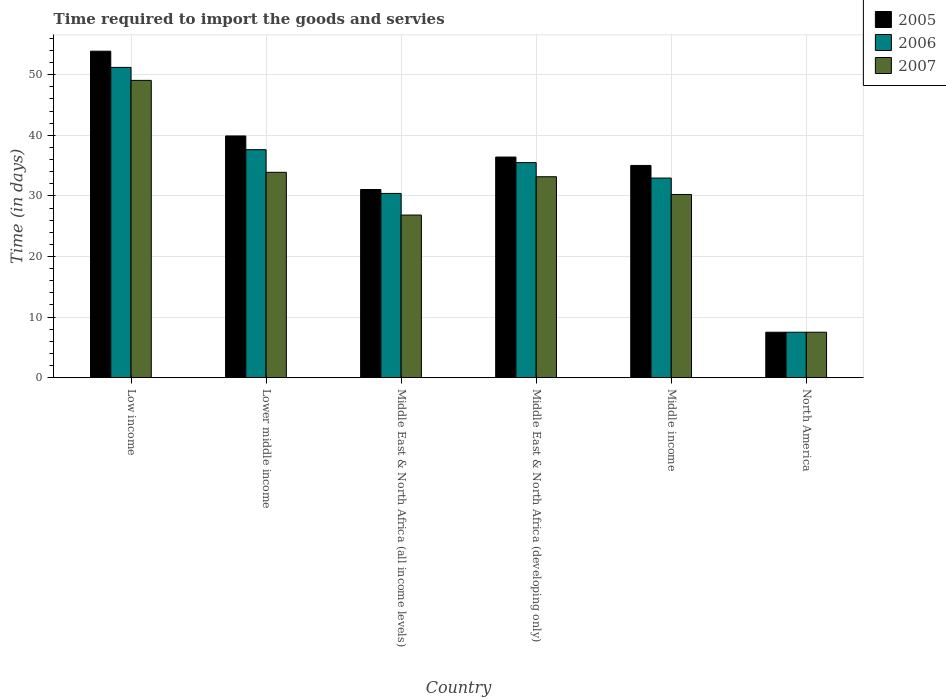How many different coloured bars are there?
Your response must be concise. 3. How many bars are there on the 2nd tick from the right?
Your answer should be very brief. 3. What is the label of the 1st group of bars from the left?
Your answer should be very brief. Low income. What is the number of days required to import the goods and services in 2005 in Middle income?
Give a very brief answer. 35.03. Across all countries, what is the maximum number of days required to import the goods and services in 2006?
Give a very brief answer. 51.21. Across all countries, what is the minimum number of days required to import the goods and services in 2005?
Ensure brevity in your answer.  7.5. In which country was the number of days required to import the goods and services in 2007 maximum?
Provide a short and direct response. Low income. In which country was the number of days required to import the goods and services in 2005 minimum?
Your answer should be very brief. North America. What is the total number of days required to import the goods and services in 2007 in the graph?
Make the answer very short. 180.72. What is the difference between the number of days required to import the goods and services in 2007 in Low income and that in Middle East & North Africa (all income levels)?
Your answer should be very brief. 22.23. What is the difference between the number of days required to import the goods and services in 2007 in Lower middle income and the number of days required to import the goods and services in 2005 in Low income?
Offer a terse response. -19.99. What is the average number of days required to import the goods and services in 2007 per country?
Make the answer very short. 30.12. What is the difference between the number of days required to import the goods and services of/in 2005 and number of days required to import the goods and services of/in 2006 in Low income?
Your response must be concise. 2.67. What is the ratio of the number of days required to import the goods and services in 2005 in Low income to that in North America?
Give a very brief answer. 7.19. Is the number of days required to import the goods and services in 2005 in Lower middle income less than that in Middle East & North Africa (all income levels)?
Provide a short and direct response. No. Is the difference between the number of days required to import the goods and services in 2005 in Low income and Lower middle income greater than the difference between the number of days required to import the goods and services in 2006 in Low income and Lower middle income?
Your answer should be very brief. Yes. What is the difference between the highest and the second highest number of days required to import the goods and services in 2005?
Your answer should be very brief. -17.47. What is the difference between the highest and the lowest number of days required to import the goods and services in 2006?
Offer a very short reply. 43.71. In how many countries, is the number of days required to import the goods and services in 2007 greater than the average number of days required to import the goods and services in 2007 taken over all countries?
Ensure brevity in your answer.  4. Is the sum of the number of days required to import the goods and services in 2005 in Lower middle income and Middle East & North Africa (all income levels) greater than the maximum number of days required to import the goods and services in 2007 across all countries?
Offer a terse response. Yes. How many bars are there?
Your answer should be compact. 18. What is the difference between two consecutive major ticks on the Y-axis?
Your response must be concise. 10. Are the values on the major ticks of Y-axis written in scientific E-notation?
Ensure brevity in your answer.  No. Does the graph contain any zero values?
Your response must be concise. No. Does the graph contain grids?
Give a very brief answer. Yes. Where does the legend appear in the graph?
Offer a very short reply. Top right. How many legend labels are there?
Keep it short and to the point. 3. What is the title of the graph?
Provide a succinct answer. Time required to import the goods and servies. Does "2001" appear as one of the legend labels in the graph?
Give a very brief answer. No. What is the label or title of the Y-axis?
Provide a short and direct response. Time (in days). What is the Time (in days) in 2005 in Low income?
Your answer should be compact. 53.89. What is the Time (in days) in 2006 in Low income?
Your response must be concise. 51.21. What is the Time (in days) of 2007 in Low income?
Provide a succinct answer. 49.07. What is the Time (in days) of 2005 in Lower middle income?
Offer a terse response. 39.9. What is the Time (in days) in 2006 in Lower middle income?
Your response must be concise. 37.63. What is the Time (in days) of 2007 in Lower middle income?
Offer a very short reply. 33.9. What is the Time (in days) of 2005 in Middle East & North Africa (all income levels)?
Offer a terse response. 31.06. What is the Time (in days) in 2006 in Middle East & North Africa (all income levels)?
Offer a very short reply. 30.41. What is the Time (in days) in 2007 in Middle East & North Africa (all income levels)?
Ensure brevity in your answer.  26.84. What is the Time (in days) in 2005 in Middle East & North Africa (developing only)?
Offer a very short reply. 36.42. What is the Time (in days) in 2006 in Middle East & North Africa (developing only)?
Ensure brevity in your answer.  35.5. What is the Time (in days) of 2007 in Middle East & North Africa (developing only)?
Give a very brief answer. 33.17. What is the Time (in days) in 2005 in Middle income?
Your response must be concise. 35.03. What is the Time (in days) in 2006 in Middle income?
Offer a very short reply. 32.95. What is the Time (in days) of 2007 in Middle income?
Your answer should be very brief. 30.24. What is the Time (in days) of 2005 in North America?
Provide a succinct answer. 7.5. What is the Time (in days) in 2006 in North America?
Give a very brief answer. 7.5. Across all countries, what is the maximum Time (in days) of 2005?
Offer a very short reply. 53.89. Across all countries, what is the maximum Time (in days) of 2006?
Your response must be concise. 51.21. Across all countries, what is the maximum Time (in days) of 2007?
Your answer should be compact. 49.07. Across all countries, what is the minimum Time (in days) of 2007?
Your response must be concise. 7.5. What is the total Time (in days) of 2005 in the graph?
Offer a very short reply. 203.79. What is the total Time (in days) in 2006 in the graph?
Your response must be concise. 195.21. What is the total Time (in days) of 2007 in the graph?
Provide a short and direct response. 180.72. What is the difference between the Time (in days) of 2005 in Low income and that in Lower middle income?
Provide a short and direct response. 13.99. What is the difference between the Time (in days) in 2006 in Low income and that in Lower middle income?
Provide a short and direct response. 13.58. What is the difference between the Time (in days) in 2007 in Low income and that in Lower middle income?
Give a very brief answer. 15.17. What is the difference between the Time (in days) in 2005 in Low income and that in Middle East & North Africa (all income levels)?
Make the answer very short. 22.83. What is the difference between the Time (in days) in 2006 in Low income and that in Middle East & North Africa (all income levels)?
Ensure brevity in your answer.  20.8. What is the difference between the Time (in days) in 2007 in Low income and that in Middle East & North Africa (all income levels)?
Provide a short and direct response. 22.23. What is the difference between the Time (in days) in 2005 in Low income and that in Middle East & North Africa (developing only)?
Your response must be concise. 17.47. What is the difference between the Time (in days) in 2006 in Low income and that in Middle East & North Africa (developing only)?
Keep it short and to the point. 15.71. What is the difference between the Time (in days) of 2007 in Low income and that in Middle East & North Africa (developing only)?
Your response must be concise. 15.9. What is the difference between the Time (in days) in 2005 in Low income and that in Middle income?
Keep it short and to the point. 18.86. What is the difference between the Time (in days) in 2006 in Low income and that in Middle income?
Ensure brevity in your answer.  18.27. What is the difference between the Time (in days) in 2007 in Low income and that in Middle income?
Your response must be concise. 18.83. What is the difference between the Time (in days) in 2005 in Low income and that in North America?
Give a very brief answer. 46.39. What is the difference between the Time (in days) in 2006 in Low income and that in North America?
Your response must be concise. 43.71. What is the difference between the Time (in days) of 2007 in Low income and that in North America?
Offer a very short reply. 41.57. What is the difference between the Time (in days) in 2005 in Lower middle income and that in Middle East & North Africa (all income levels)?
Provide a succinct answer. 8.84. What is the difference between the Time (in days) of 2006 in Lower middle income and that in Middle East & North Africa (all income levels)?
Your answer should be very brief. 7.22. What is the difference between the Time (in days) of 2007 in Lower middle income and that in Middle East & North Africa (all income levels)?
Your answer should be very brief. 7.06. What is the difference between the Time (in days) of 2005 in Lower middle income and that in Middle East & North Africa (developing only)?
Give a very brief answer. 3.48. What is the difference between the Time (in days) in 2006 in Lower middle income and that in Middle East & North Africa (developing only)?
Your response must be concise. 2.13. What is the difference between the Time (in days) in 2007 in Lower middle income and that in Middle East & North Africa (developing only)?
Give a very brief answer. 0.73. What is the difference between the Time (in days) in 2005 in Lower middle income and that in Middle income?
Your answer should be compact. 4.87. What is the difference between the Time (in days) in 2006 in Lower middle income and that in Middle income?
Ensure brevity in your answer.  4.68. What is the difference between the Time (in days) of 2007 in Lower middle income and that in Middle income?
Your answer should be very brief. 3.66. What is the difference between the Time (in days) of 2005 in Lower middle income and that in North America?
Make the answer very short. 32.4. What is the difference between the Time (in days) in 2006 in Lower middle income and that in North America?
Keep it short and to the point. 30.13. What is the difference between the Time (in days) in 2007 in Lower middle income and that in North America?
Give a very brief answer. 26.4. What is the difference between the Time (in days) of 2005 in Middle East & North Africa (all income levels) and that in Middle East & North Africa (developing only)?
Your response must be concise. -5.36. What is the difference between the Time (in days) of 2006 in Middle East & North Africa (all income levels) and that in Middle East & North Africa (developing only)?
Offer a very short reply. -5.09. What is the difference between the Time (in days) of 2007 in Middle East & North Africa (all income levels) and that in Middle East & North Africa (developing only)?
Keep it short and to the point. -6.32. What is the difference between the Time (in days) of 2005 in Middle East & North Africa (all income levels) and that in Middle income?
Offer a very short reply. -3.97. What is the difference between the Time (in days) of 2006 in Middle East & North Africa (all income levels) and that in Middle income?
Offer a very short reply. -2.54. What is the difference between the Time (in days) of 2007 in Middle East & North Africa (all income levels) and that in Middle income?
Make the answer very short. -3.4. What is the difference between the Time (in days) of 2005 in Middle East & North Africa (all income levels) and that in North America?
Your answer should be very brief. 23.56. What is the difference between the Time (in days) of 2006 in Middle East & North Africa (all income levels) and that in North America?
Ensure brevity in your answer.  22.91. What is the difference between the Time (in days) of 2007 in Middle East & North Africa (all income levels) and that in North America?
Give a very brief answer. 19.34. What is the difference between the Time (in days) of 2005 in Middle East & North Africa (developing only) and that in Middle income?
Keep it short and to the point. 1.39. What is the difference between the Time (in days) in 2006 in Middle East & North Africa (developing only) and that in Middle income?
Provide a short and direct response. 2.55. What is the difference between the Time (in days) of 2007 in Middle East & North Africa (developing only) and that in Middle income?
Offer a very short reply. 2.93. What is the difference between the Time (in days) in 2005 in Middle East & North Africa (developing only) and that in North America?
Offer a very short reply. 28.92. What is the difference between the Time (in days) in 2007 in Middle East & North Africa (developing only) and that in North America?
Offer a very short reply. 25.67. What is the difference between the Time (in days) of 2005 in Middle income and that in North America?
Provide a short and direct response. 27.53. What is the difference between the Time (in days) in 2006 in Middle income and that in North America?
Your response must be concise. 25.45. What is the difference between the Time (in days) of 2007 in Middle income and that in North America?
Offer a very short reply. 22.74. What is the difference between the Time (in days) in 2005 in Low income and the Time (in days) in 2006 in Lower middle income?
Provide a short and direct response. 16.26. What is the difference between the Time (in days) of 2005 in Low income and the Time (in days) of 2007 in Lower middle income?
Your answer should be compact. 19.99. What is the difference between the Time (in days) of 2006 in Low income and the Time (in days) of 2007 in Lower middle income?
Ensure brevity in your answer.  17.32. What is the difference between the Time (in days) in 2005 in Low income and the Time (in days) in 2006 in Middle East & North Africa (all income levels)?
Your answer should be very brief. 23.48. What is the difference between the Time (in days) in 2005 in Low income and the Time (in days) in 2007 in Middle East & North Africa (all income levels)?
Ensure brevity in your answer.  27.05. What is the difference between the Time (in days) in 2006 in Low income and the Time (in days) in 2007 in Middle East & North Africa (all income levels)?
Your answer should be very brief. 24.37. What is the difference between the Time (in days) of 2005 in Low income and the Time (in days) of 2006 in Middle East & North Africa (developing only)?
Give a very brief answer. 18.39. What is the difference between the Time (in days) of 2005 in Low income and the Time (in days) of 2007 in Middle East & North Africa (developing only)?
Provide a short and direct response. 20.72. What is the difference between the Time (in days) of 2006 in Low income and the Time (in days) of 2007 in Middle East & North Africa (developing only)?
Your answer should be very brief. 18.05. What is the difference between the Time (in days) of 2005 in Low income and the Time (in days) of 2006 in Middle income?
Keep it short and to the point. 20.94. What is the difference between the Time (in days) in 2005 in Low income and the Time (in days) in 2007 in Middle income?
Provide a short and direct response. 23.65. What is the difference between the Time (in days) in 2006 in Low income and the Time (in days) in 2007 in Middle income?
Provide a short and direct response. 20.98. What is the difference between the Time (in days) of 2005 in Low income and the Time (in days) of 2006 in North America?
Your answer should be compact. 46.39. What is the difference between the Time (in days) of 2005 in Low income and the Time (in days) of 2007 in North America?
Your answer should be very brief. 46.39. What is the difference between the Time (in days) of 2006 in Low income and the Time (in days) of 2007 in North America?
Your answer should be very brief. 43.71. What is the difference between the Time (in days) in 2005 in Lower middle income and the Time (in days) in 2006 in Middle East & North Africa (all income levels)?
Ensure brevity in your answer.  9.49. What is the difference between the Time (in days) of 2005 in Lower middle income and the Time (in days) of 2007 in Middle East & North Africa (all income levels)?
Your response must be concise. 13.06. What is the difference between the Time (in days) in 2006 in Lower middle income and the Time (in days) in 2007 in Middle East & North Africa (all income levels)?
Make the answer very short. 10.79. What is the difference between the Time (in days) of 2005 in Lower middle income and the Time (in days) of 2006 in Middle East & North Africa (developing only)?
Offer a terse response. 4.4. What is the difference between the Time (in days) in 2005 in Lower middle income and the Time (in days) in 2007 in Middle East & North Africa (developing only)?
Give a very brief answer. 6.73. What is the difference between the Time (in days) in 2006 in Lower middle income and the Time (in days) in 2007 in Middle East & North Africa (developing only)?
Offer a very short reply. 4.47. What is the difference between the Time (in days) of 2005 in Lower middle income and the Time (in days) of 2006 in Middle income?
Offer a terse response. 6.95. What is the difference between the Time (in days) in 2005 in Lower middle income and the Time (in days) in 2007 in Middle income?
Make the answer very short. 9.66. What is the difference between the Time (in days) in 2006 in Lower middle income and the Time (in days) in 2007 in Middle income?
Keep it short and to the point. 7.4. What is the difference between the Time (in days) of 2005 in Lower middle income and the Time (in days) of 2006 in North America?
Give a very brief answer. 32.4. What is the difference between the Time (in days) in 2005 in Lower middle income and the Time (in days) in 2007 in North America?
Offer a terse response. 32.4. What is the difference between the Time (in days) in 2006 in Lower middle income and the Time (in days) in 2007 in North America?
Offer a very short reply. 30.13. What is the difference between the Time (in days) of 2005 in Middle East & North Africa (all income levels) and the Time (in days) of 2006 in Middle East & North Africa (developing only)?
Ensure brevity in your answer.  -4.44. What is the difference between the Time (in days) of 2005 in Middle East & North Africa (all income levels) and the Time (in days) of 2007 in Middle East & North Africa (developing only)?
Your response must be concise. -2.11. What is the difference between the Time (in days) of 2006 in Middle East & North Africa (all income levels) and the Time (in days) of 2007 in Middle East & North Africa (developing only)?
Give a very brief answer. -2.75. What is the difference between the Time (in days) in 2005 in Middle East & North Africa (all income levels) and the Time (in days) in 2006 in Middle income?
Your response must be concise. -1.89. What is the difference between the Time (in days) in 2005 in Middle East & North Africa (all income levels) and the Time (in days) in 2007 in Middle income?
Offer a very short reply. 0.82. What is the difference between the Time (in days) in 2006 in Middle East & North Africa (all income levels) and the Time (in days) in 2007 in Middle income?
Offer a very short reply. 0.17. What is the difference between the Time (in days) in 2005 in Middle East & North Africa (all income levels) and the Time (in days) in 2006 in North America?
Your response must be concise. 23.56. What is the difference between the Time (in days) in 2005 in Middle East & North Africa (all income levels) and the Time (in days) in 2007 in North America?
Provide a short and direct response. 23.56. What is the difference between the Time (in days) of 2006 in Middle East & North Africa (all income levels) and the Time (in days) of 2007 in North America?
Offer a very short reply. 22.91. What is the difference between the Time (in days) in 2005 in Middle East & North Africa (developing only) and the Time (in days) in 2006 in Middle income?
Make the answer very short. 3.47. What is the difference between the Time (in days) in 2005 in Middle East & North Africa (developing only) and the Time (in days) in 2007 in Middle income?
Your response must be concise. 6.18. What is the difference between the Time (in days) in 2006 in Middle East & North Africa (developing only) and the Time (in days) in 2007 in Middle income?
Offer a terse response. 5.26. What is the difference between the Time (in days) in 2005 in Middle East & North Africa (developing only) and the Time (in days) in 2006 in North America?
Provide a succinct answer. 28.92. What is the difference between the Time (in days) in 2005 in Middle East & North Africa (developing only) and the Time (in days) in 2007 in North America?
Make the answer very short. 28.92. What is the difference between the Time (in days) in 2006 in Middle East & North Africa (developing only) and the Time (in days) in 2007 in North America?
Your answer should be very brief. 28. What is the difference between the Time (in days) in 2005 in Middle income and the Time (in days) in 2006 in North America?
Offer a very short reply. 27.53. What is the difference between the Time (in days) of 2005 in Middle income and the Time (in days) of 2007 in North America?
Keep it short and to the point. 27.53. What is the difference between the Time (in days) in 2006 in Middle income and the Time (in days) in 2007 in North America?
Keep it short and to the point. 25.45. What is the average Time (in days) in 2005 per country?
Your response must be concise. 33.97. What is the average Time (in days) of 2006 per country?
Provide a short and direct response. 32.53. What is the average Time (in days) of 2007 per country?
Give a very brief answer. 30.12. What is the difference between the Time (in days) of 2005 and Time (in days) of 2006 in Low income?
Ensure brevity in your answer.  2.67. What is the difference between the Time (in days) in 2005 and Time (in days) in 2007 in Low income?
Your answer should be compact. 4.82. What is the difference between the Time (in days) of 2006 and Time (in days) of 2007 in Low income?
Your answer should be compact. 2.14. What is the difference between the Time (in days) of 2005 and Time (in days) of 2006 in Lower middle income?
Provide a short and direct response. 2.27. What is the difference between the Time (in days) of 2006 and Time (in days) of 2007 in Lower middle income?
Keep it short and to the point. 3.73. What is the difference between the Time (in days) in 2005 and Time (in days) in 2006 in Middle East & North Africa (all income levels)?
Offer a terse response. 0.65. What is the difference between the Time (in days) in 2005 and Time (in days) in 2007 in Middle East & North Africa (all income levels)?
Keep it short and to the point. 4.22. What is the difference between the Time (in days) in 2006 and Time (in days) in 2007 in Middle East & North Africa (all income levels)?
Keep it short and to the point. 3.57. What is the difference between the Time (in days) of 2005 and Time (in days) of 2006 in Middle East & North Africa (developing only)?
Ensure brevity in your answer.  0.92. What is the difference between the Time (in days) of 2005 and Time (in days) of 2007 in Middle East & North Africa (developing only)?
Offer a terse response. 3.25. What is the difference between the Time (in days) of 2006 and Time (in days) of 2007 in Middle East & North Africa (developing only)?
Make the answer very short. 2.33. What is the difference between the Time (in days) of 2005 and Time (in days) of 2006 in Middle income?
Keep it short and to the point. 2.08. What is the difference between the Time (in days) of 2005 and Time (in days) of 2007 in Middle income?
Your response must be concise. 4.79. What is the difference between the Time (in days) in 2006 and Time (in days) in 2007 in Middle income?
Make the answer very short. 2.71. What is the difference between the Time (in days) of 2005 and Time (in days) of 2006 in North America?
Keep it short and to the point. 0. What is the difference between the Time (in days) of 2006 and Time (in days) of 2007 in North America?
Offer a terse response. 0. What is the ratio of the Time (in days) of 2005 in Low income to that in Lower middle income?
Provide a succinct answer. 1.35. What is the ratio of the Time (in days) of 2006 in Low income to that in Lower middle income?
Your answer should be very brief. 1.36. What is the ratio of the Time (in days) in 2007 in Low income to that in Lower middle income?
Your answer should be very brief. 1.45. What is the ratio of the Time (in days) in 2005 in Low income to that in Middle East & North Africa (all income levels)?
Offer a terse response. 1.74. What is the ratio of the Time (in days) of 2006 in Low income to that in Middle East & North Africa (all income levels)?
Keep it short and to the point. 1.68. What is the ratio of the Time (in days) of 2007 in Low income to that in Middle East & North Africa (all income levels)?
Offer a very short reply. 1.83. What is the ratio of the Time (in days) of 2005 in Low income to that in Middle East & North Africa (developing only)?
Give a very brief answer. 1.48. What is the ratio of the Time (in days) of 2006 in Low income to that in Middle East & North Africa (developing only)?
Provide a short and direct response. 1.44. What is the ratio of the Time (in days) of 2007 in Low income to that in Middle East & North Africa (developing only)?
Keep it short and to the point. 1.48. What is the ratio of the Time (in days) in 2005 in Low income to that in Middle income?
Keep it short and to the point. 1.54. What is the ratio of the Time (in days) of 2006 in Low income to that in Middle income?
Ensure brevity in your answer.  1.55. What is the ratio of the Time (in days) of 2007 in Low income to that in Middle income?
Ensure brevity in your answer.  1.62. What is the ratio of the Time (in days) of 2005 in Low income to that in North America?
Provide a short and direct response. 7.19. What is the ratio of the Time (in days) of 2006 in Low income to that in North America?
Ensure brevity in your answer.  6.83. What is the ratio of the Time (in days) in 2007 in Low income to that in North America?
Offer a very short reply. 6.54. What is the ratio of the Time (in days) of 2005 in Lower middle income to that in Middle East & North Africa (all income levels)?
Make the answer very short. 1.28. What is the ratio of the Time (in days) in 2006 in Lower middle income to that in Middle East & North Africa (all income levels)?
Keep it short and to the point. 1.24. What is the ratio of the Time (in days) of 2007 in Lower middle income to that in Middle East & North Africa (all income levels)?
Give a very brief answer. 1.26. What is the ratio of the Time (in days) of 2005 in Lower middle income to that in Middle East & North Africa (developing only)?
Ensure brevity in your answer.  1.1. What is the ratio of the Time (in days) of 2006 in Lower middle income to that in Middle East & North Africa (developing only)?
Offer a terse response. 1.06. What is the ratio of the Time (in days) of 2007 in Lower middle income to that in Middle East & North Africa (developing only)?
Provide a succinct answer. 1.02. What is the ratio of the Time (in days) of 2005 in Lower middle income to that in Middle income?
Keep it short and to the point. 1.14. What is the ratio of the Time (in days) of 2006 in Lower middle income to that in Middle income?
Keep it short and to the point. 1.14. What is the ratio of the Time (in days) of 2007 in Lower middle income to that in Middle income?
Give a very brief answer. 1.12. What is the ratio of the Time (in days) in 2005 in Lower middle income to that in North America?
Give a very brief answer. 5.32. What is the ratio of the Time (in days) in 2006 in Lower middle income to that in North America?
Your answer should be very brief. 5.02. What is the ratio of the Time (in days) in 2007 in Lower middle income to that in North America?
Your answer should be very brief. 4.52. What is the ratio of the Time (in days) in 2005 in Middle East & North Africa (all income levels) to that in Middle East & North Africa (developing only)?
Make the answer very short. 0.85. What is the ratio of the Time (in days) in 2006 in Middle East & North Africa (all income levels) to that in Middle East & North Africa (developing only)?
Make the answer very short. 0.86. What is the ratio of the Time (in days) of 2007 in Middle East & North Africa (all income levels) to that in Middle East & North Africa (developing only)?
Provide a short and direct response. 0.81. What is the ratio of the Time (in days) of 2005 in Middle East & North Africa (all income levels) to that in Middle income?
Your answer should be compact. 0.89. What is the ratio of the Time (in days) of 2006 in Middle East & North Africa (all income levels) to that in Middle income?
Give a very brief answer. 0.92. What is the ratio of the Time (in days) of 2007 in Middle East & North Africa (all income levels) to that in Middle income?
Your answer should be very brief. 0.89. What is the ratio of the Time (in days) of 2005 in Middle East & North Africa (all income levels) to that in North America?
Keep it short and to the point. 4.14. What is the ratio of the Time (in days) of 2006 in Middle East & North Africa (all income levels) to that in North America?
Your response must be concise. 4.05. What is the ratio of the Time (in days) in 2007 in Middle East & North Africa (all income levels) to that in North America?
Offer a very short reply. 3.58. What is the ratio of the Time (in days) of 2005 in Middle East & North Africa (developing only) to that in Middle income?
Provide a succinct answer. 1.04. What is the ratio of the Time (in days) in 2006 in Middle East & North Africa (developing only) to that in Middle income?
Give a very brief answer. 1.08. What is the ratio of the Time (in days) in 2007 in Middle East & North Africa (developing only) to that in Middle income?
Keep it short and to the point. 1.1. What is the ratio of the Time (in days) in 2005 in Middle East & North Africa (developing only) to that in North America?
Offer a very short reply. 4.86. What is the ratio of the Time (in days) of 2006 in Middle East & North Africa (developing only) to that in North America?
Offer a terse response. 4.73. What is the ratio of the Time (in days) in 2007 in Middle East & North Africa (developing only) to that in North America?
Your answer should be compact. 4.42. What is the ratio of the Time (in days) in 2005 in Middle income to that in North America?
Keep it short and to the point. 4.67. What is the ratio of the Time (in days) of 2006 in Middle income to that in North America?
Give a very brief answer. 4.39. What is the ratio of the Time (in days) of 2007 in Middle income to that in North America?
Your answer should be very brief. 4.03. What is the difference between the highest and the second highest Time (in days) in 2005?
Your answer should be compact. 13.99. What is the difference between the highest and the second highest Time (in days) of 2006?
Your response must be concise. 13.58. What is the difference between the highest and the second highest Time (in days) in 2007?
Provide a short and direct response. 15.17. What is the difference between the highest and the lowest Time (in days) in 2005?
Your answer should be compact. 46.39. What is the difference between the highest and the lowest Time (in days) in 2006?
Keep it short and to the point. 43.71. What is the difference between the highest and the lowest Time (in days) of 2007?
Keep it short and to the point. 41.57. 